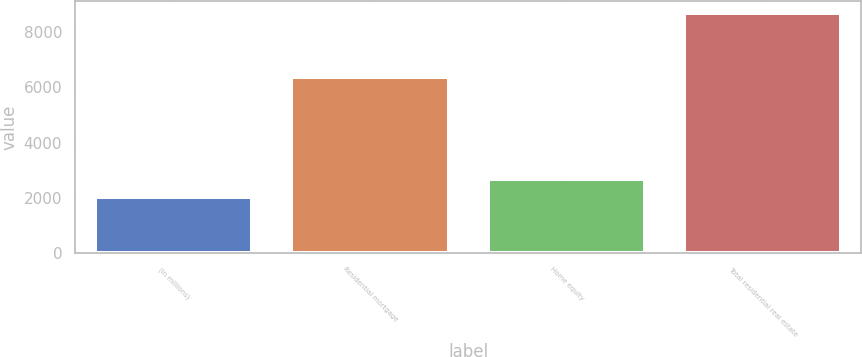<chart> <loc_0><loc_0><loc_500><loc_500><bar_chart><fcel>(in millions)<fcel>Residential mortgage<fcel>Home equity<fcel>Total residential real estate<nl><fcel>2016<fcel>6376<fcel>2683.1<fcel>8687<nl></chart> 